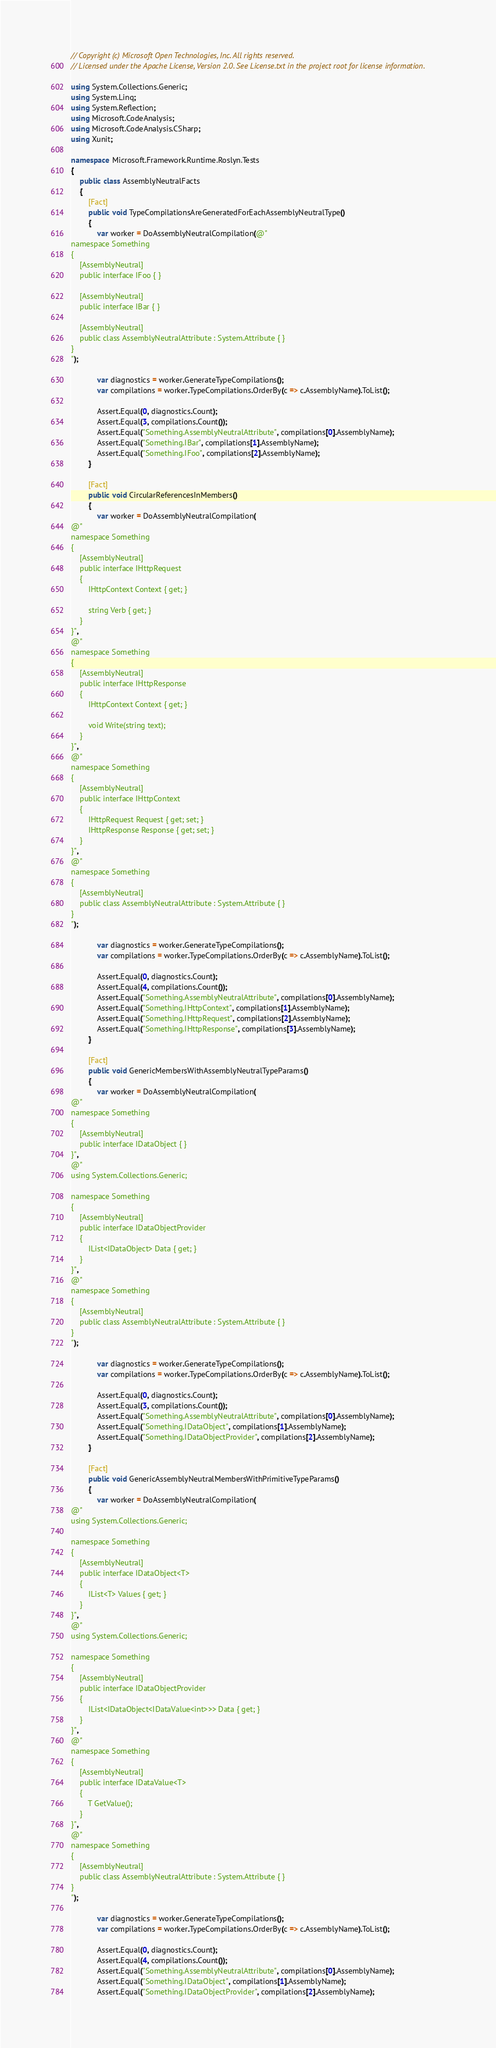Convert code to text. <code><loc_0><loc_0><loc_500><loc_500><_C#_>// Copyright (c) Microsoft Open Technologies, Inc. All rights reserved.
// Licensed under the Apache License, Version 2.0. See License.txt in the project root for license information.

using System.Collections.Generic;
using System.Linq;
using System.Reflection;
using Microsoft.CodeAnalysis;
using Microsoft.CodeAnalysis.CSharp;
using Xunit;

namespace Microsoft.Framework.Runtime.Roslyn.Tests
{
    public class AssemblyNeutralFacts
    {
        [Fact]
        public void TypeCompilationsAreGeneratedForEachAssemblyNeutralType()
        {
            var worker = DoAssemblyNeutralCompilation(@"
namespace Something
{
    [AssemblyNeutral]
    public interface IFoo { }

    [AssemblyNeutral]
    public interface IBar { }

    [AssemblyNeutral]
    public class AssemblyNeutralAttribute : System.Attribute { }
}
");

            var diagnostics = worker.GenerateTypeCompilations();
            var compilations = worker.TypeCompilations.OrderBy(c => c.AssemblyName).ToList();

            Assert.Equal(0, diagnostics.Count);
            Assert.Equal(3, compilations.Count());
            Assert.Equal("Something.AssemblyNeutralAttribute", compilations[0].AssemblyName);
            Assert.Equal("Something.IBar", compilations[1].AssemblyName);
            Assert.Equal("Something.IFoo", compilations[2].AssemblyName);
        }

        [Fact]
        public void CircularReferencesInMembers()
        {
            var worker = DoAssemblyNeutralCompilation(
@"
namespace Something
{
    [AssemblyNeutral]
    public interface IHttpRequest 
    { 
        IHttpContext Context { get; }

        string Verb { get; } 
    }
}",
@"
namespace Something
{
    [AssemblyNeutral]
    public interface IHttpResponse 
    { 
        IHttpContext Context { get; }

        void Write(string text);
    }
}",
@"
namespace Something
{
    [AssemblyNeutral]
    public interface IHttpContext 
    { 
        IHttpRequest Request { get; set; }
        IHttpResponse Response { get; set; }
    }
}",
@"
namespace Something
{
    [AssemblyNeutral]
    public class AssemblyNeutralAttribute : System.Attribute { }
}
");

            var diagnostics = worker.GenerateTypeCompilations();
            var compilations = worker.TypeCompilations.OrderBy(c => c.AssemblyName).ToList();

            Assert.Equal(0, diagnostics.Count);
            Assert.Equal(4, compilations.Count());
            Assert.Equal("Something.AssemblyNeutralAttribute", compilations[0].AssemblyName);
            Assert.Equal("Something.IHttpContext", compilations[1].AssemblyName);
            Assert.Equal("Something.IHttpRequest", compilations[2].AssemblyName);
            Assert.Equal("Something.IHttpResponse", compilations[3].AssemblyName);
        }

        [Fact]
        public void GenericMembersWithAssemblyNeutralTypeParams()
        {
            var worker = DoAssemblyNeutralCompilation(
@"
namespace Something
{
    [AssemblyNeutral]
    public interface IDataObject { }
}",
@"
using System.Collections.Generic;

namespace Something
{
    [AssemblyNeutral]
    public interface IDataObjectProvider 
    { 
        IList<IDataObject> Data { get; }
    }
}",
@"
namespace Something
{
    [AssemblyNeutral]
    public class AssemblyNeutralAttribute : System.Attribute { }
}
");

            var diagnostics = worker.GenerateTypeCompilations();
            var compilations = worker.TypeCompilations.OrderBy(c => c.AssemblyName).ToList();

            Assert.Equal(0, diagnostics.Count);
            Assert.Equal(3, compilations.Count());
            Assert.Equal("Something.AssemblyNeutralAttribute", compilations[0].AssemblyName);
            Assert.Equal("Something.IDataObject", compilations[1].AssemblyName);
            Assert.Equal("Something.IDataObjectProvider", compilations[2].AssemblyName);
        }

        [Fact]
        public void GenericAssemblyNeutralMembersWithPrimitiveTypeParams()
        {
            var worker = DoAssemblyNeutralCompilation(
@"
using System.Collections.Generic;

namespace Something
{
    [AssemblyNeutral]
    public interface IDataObject<T> 
    { 
        IList<T> Values { get; } 
    }
}",
@"
using System.Collections.Generic;

namespace Something
{
    [AssemblyNeutral]
    public interface IDataObjectProvider 
    { 
        IList<IDataObject<IDataValue<int>>> Data { get; }
    }
}",
@"
namespace Something
{
    [AssemblyNeutral]
    public interface IDataValue<T> 
    { 
        T GetValue();
    }
}",
@"
namespace Something
{
    [AssemblyNeutral]
    public class AssemblyNeutralAttribute : System.Attribute { }
}
");

            var diagnostics = worker.GenerateTypeCompilations();
            var compilations = worker.TypeCompilations.OrderBy(c => c.AssemblyName).ToList();

            Assert.Equal(0, diagnostics.Count);
            Assert.Equal(4, compilations.Count());
            Assert.Equal("Something.AssemblyNeutralAttribute", compilations[0].AssemblyName);
            Assert.Equal("Something.IDataObject", compilations[1].AssemblyName);
            Assert.Equal("Something.IDataObjectProvider", compilations[2].AssemblyName);</code> 